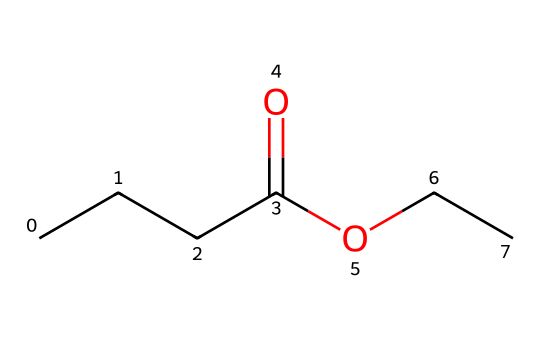How many carbon atoms are in ethyl butyrate? Counting the carbon atoms in the provided SMILES, there are five carbon atoms in total: four in the butyric acid portion (CCCC) and one from the ethyl group (CC).
Answer: five What type of functional group is present in ethyl butyrate? The structure contains a carboxylate functional group indicated by the -O(C=O) structure; this means it is an ester.
Answer: ester What is the total number of hydrogen atoms in ethyl butyrate? The total number of hydrogen atoms can be determined by counting: four from the butyric part (C3H7) plus five from the ethyl part (C2H5), totaling nine hydrogen atoms.
Answer: nine Why is ethyl butyrate often associated with fruity aromas? Ethyl butyrate has an ester functional group which is commonly found in many fruit flavors and scents, contributing to the perception of a fruity aroma.
Answer: fruity aroma Which part of the molecule is responsible for its fruity flavor? The ester functional group (the section –O–C(=O)–) is typically responsible for the fruity flavors found in many compounds, including ethyl butyrate.
Answer: ester functional group How many oxygen atoms are present in ethyl butyrate? The structure includes two oxygen atoms: one from the carbonyl (C=O) part and one from the ether (–O–) part of the ester.
Answer: two 